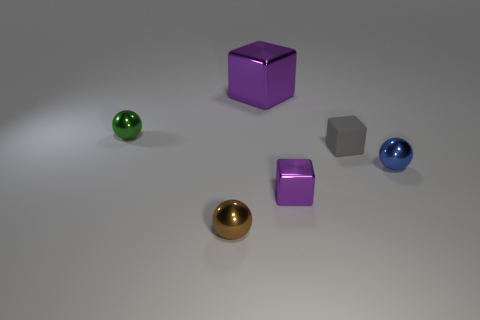Subtract all metallic cubes. How many cubes are left? 1 Add 3 big purple cubes. How many objects exist? 9 Subtract all brown balls. How many balls are left? 2 Subtract all gray cubes. Subtract all cyan cylinders. How many cubes are left? 2 Subtract all red cylinders. How many purple blocks are left? 2 Subtract all small rubber objects. Subtract all small blue balls. How many objects are left? 4 Add 3 brown objects. How many brown objects are left? 4 Add 5 large red things. How many large red things exist? 5 Subtract 2 purple blocks. How many objects are left? 4 Subtract 3 balls. How many balls are left? 0 